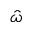Convert formula to latex. <formula><loc_0><loc_0><loc_500><loc_500>\hat { \omega }</formula> 